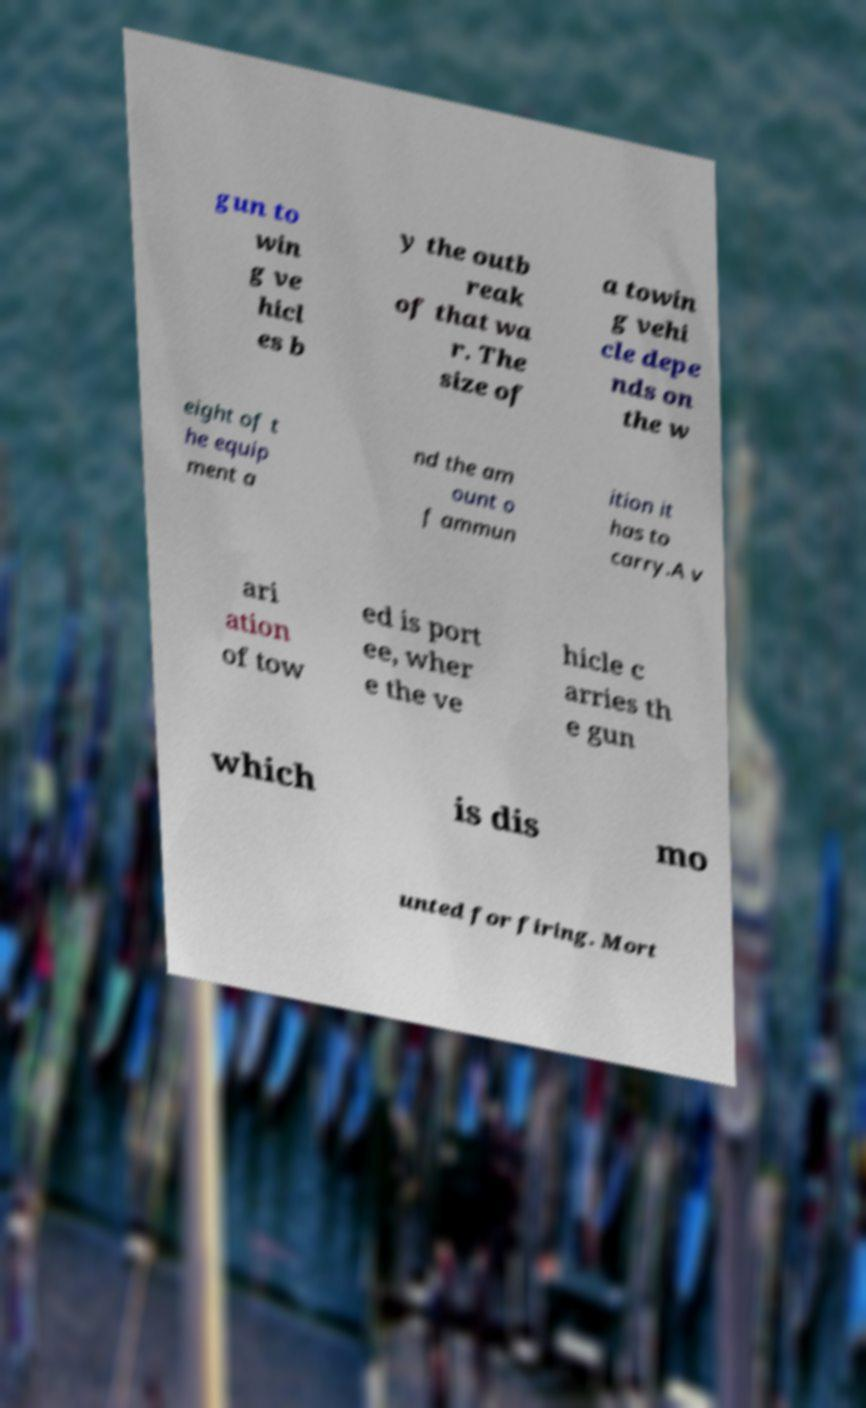Can you accurately transcribe the text from the provided image for me? gun to win g ve hicl es b y the outb reak of that wa r. The size of a towin g vehi cle depe nds on the w eight of t he equip ment a nd the am ount o f ammun ition it has to carry.A v ari ation of tow ed is port ee, wher e the ve hicle c arries th e gun which is dis mo unted for firing. Mort 